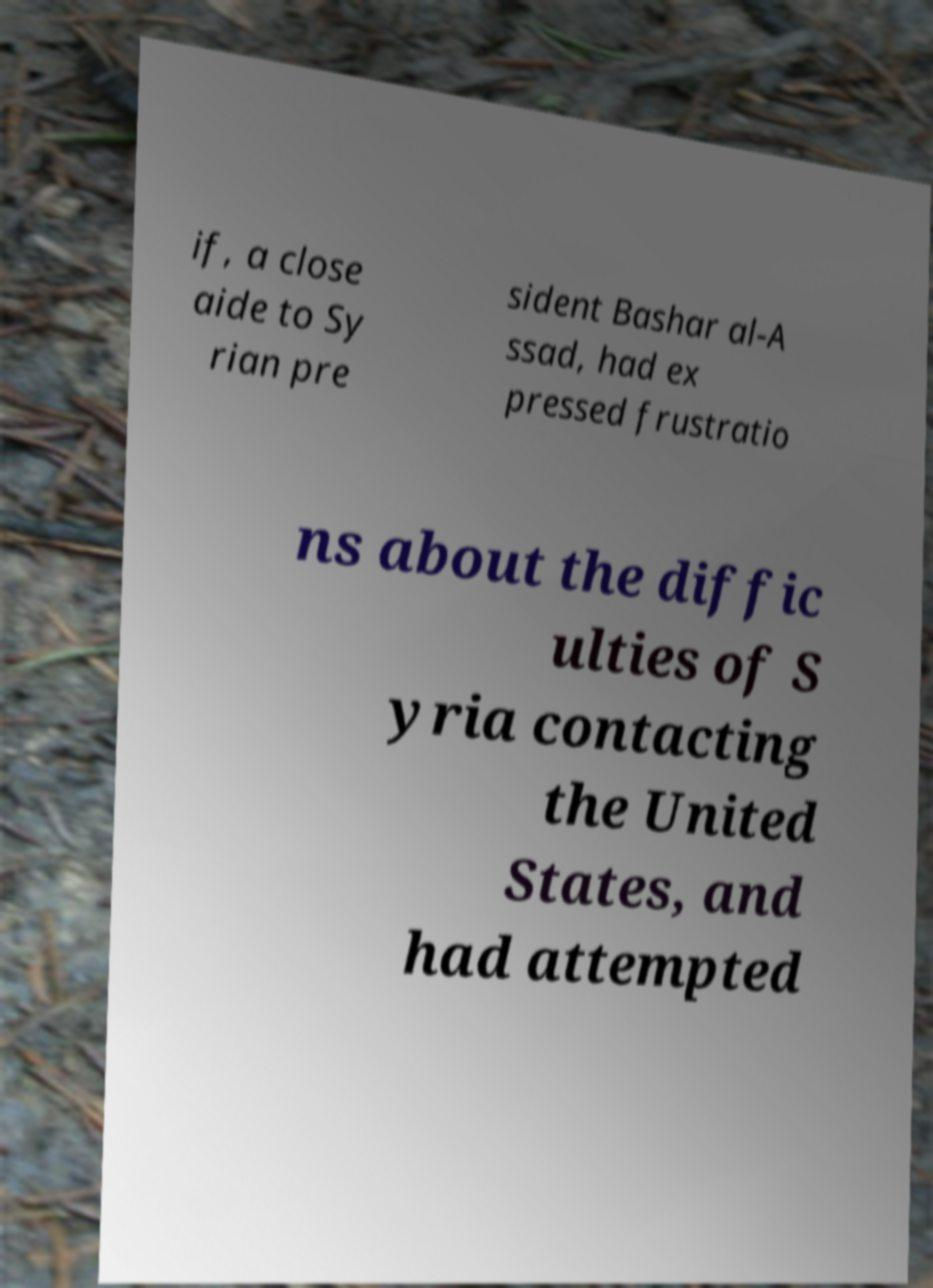I need the written content from this picture converted into text. Can you do that? if, a close aide to Sy rian pre sident Bashar al-A ssad, had ex pressed frustratio ns about the diffic ulties of S yria contacting the United States, and had attempted 